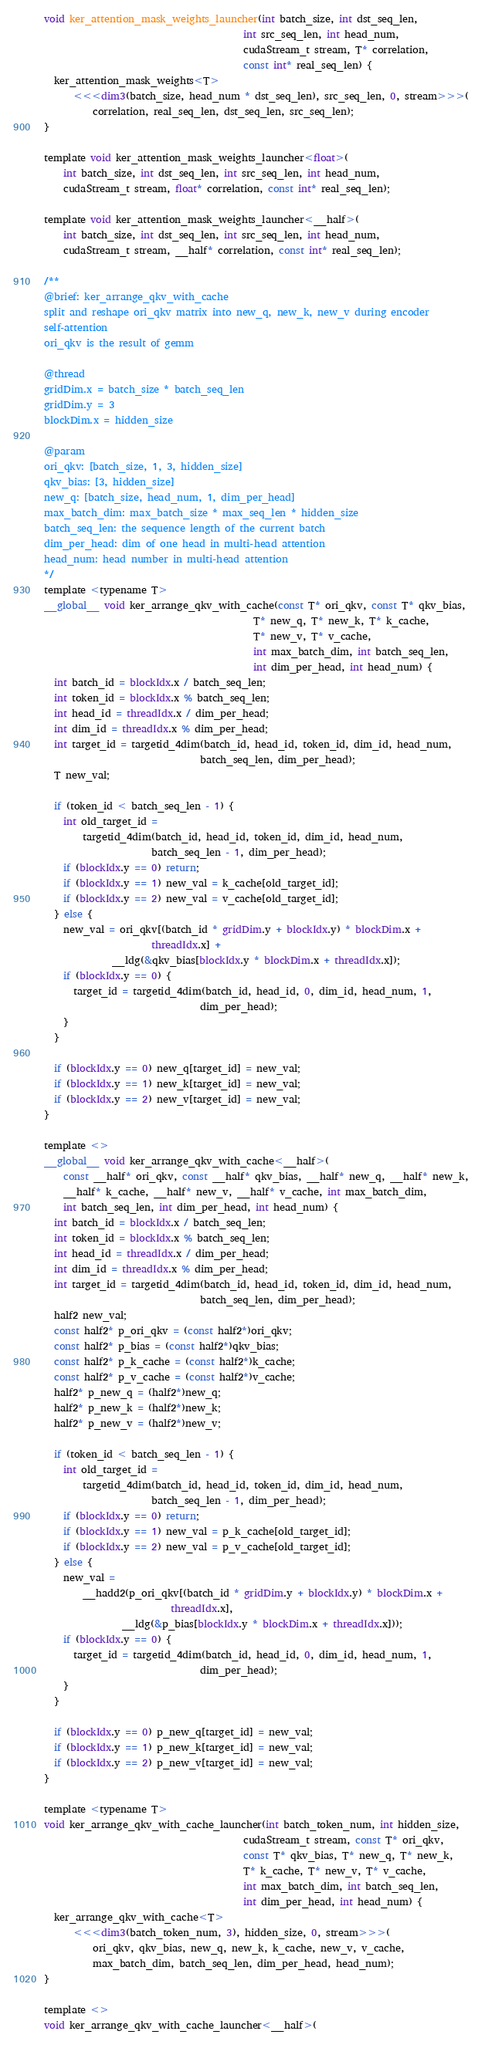Convert code to text. <code><loc_0><loc_0><loc_500><loc_500><_Cuda_>void ker_attention_mask_weights_launcher(int batch_size, int dst_seq_len,
                                         int src_seq_len, int head_num,
                                         cudaStream_t stream, T* correlation,
                                         const int* real_seq_len) {
  ker_attention_mask_weights<T>
      <<<dim3(batch_size, head_num * dst_seq_len), src_seq_len, 0, stream>>>(
          correlation, real_seq_len, dst_seq_len, src_seq_len);
}

template void ker_attention_mask_weights_launcher<float>(
    int batch_size, int dst_seq_len, int src_seq_len, int head_num,
    cudaStream_t stream, float* correlation, const int* real_seq_len);

template void ker_attention_mask_weights_launcher<__half>(
    int batch_size, int dst_seq_len, int src_seq_len, int head_num,
    cudaStream_t stream, __half* correlation, const int* real_seq_len);

/**
@brief: ker_arrange_qkv_with_cache
split and reshape ori_qkv matrix into new_q, new_k, new_v during encoder
self-attention
ori_qkv is the result of gemm

@thread
gridDim.x = batch_size * batch_seq_len
gridDim.y = 3
blockDim.x = hidden_size

@param
ori_qkv: [batch_size, 1, 3, hidden_size]
qkv_bias: [3, hidden_size]
new_q: [batch_size, head_num, 1, dim_per_head]
max_batch_dim: max_batch_size * max_seq_len * hidden_size
batch_seq_len: the sequence length of the current batch
dim_per_head: dim of one head in multi-head attention
head_num: head number in multi-head attention
*/
template <typename T>
__global__ void ker_arrange_qkv_with_cache(const T* ori_qkv, const T* qkv_bias,
                                           T* new_q, T* new_k, T* k_cache,
                                           T* new_v, T* v_cache,
                                           int max_batch_dim, int batch_seq_len,
                                           int dim_per_head, int head_num) {
  int batch_id = blockIdx.x / batch_seq_len;
  int token_id = blockIdx.x % batch_seq_len;
  int head_id = threadIdx.x / dim_per_head;
  int dim_id = threadIdx.x % dim_per_head;
  int target_id = targetid_4dim(batch_id, head_id, token_id, dim_id, head_num,
                                batch_seq_len, dim_per_head);
  T new_val;

  if (token_id < batch_seq_len - 1) {
    int old_target_id =
        targetid_4dim(batch_id, head_id, token_id, dim_id, head_num,
                      batch_seq_len - 1, dim_per_head);
    if (blockIdx.y == 0) return;
    if (blockIdx.y == 1) new_val = k_cache[old_target_id];
    if (blockIdx.y == 2) new_val = v_cache[old_target_id];
  } else {
    new_val = ori_qkv[(batch_id * gridDim.y + blockIdx.y) * blockDim.x +
                      threadIdx.x] +
              __ldg(&qkv_bias[blockIdx.y * blockDim.x + threadIdx.x]);
    if (blockIdx.y == 0) {
      target_id = targetid_4dim(batch_id, head_id, 0, dim_id, head_num, 1,
                                dim_per_head);
    }
  }

  if (blockIdx.y == 0) new_q[target_id] = new_val;
  if (blockIdx.y == 1) new_k[target_id] = new_val;
  if (blockIdx.y == 2) new_v[target_id] = new_val;
}

template <>
__global__ void ker_arrange_qkv_with_cache<__half>(
    const __half* ori_qkv, const __half* qkv_bias, __half* new_q, __half* new_k,
    __half* k_cache, __half* new_v, __half* v_cache, int max_batch_dim,
    int batch_seq_len, int dim_per_head, int head_num) {
  int batch_id = blockIdx.x / batch_seq_len;
  int token_id = blockIdx.x % batch_seq_len;
  int head_id = threadIdx.x / dim_per_head;
  int dim_id = threadIdx.x % dim_per_head;
  int target_id = targetid_4dim(batch_id, head_id, token_id, dim_id, head_num,
                                batch_seq_len, dim_per_head);
  half2 new_val;
  const half2* p_ori_qkv = (const half2*)ori_qkv;
  const half2* p_bias = (const half2*)qkv_bias;
  const half2* p_k_cache = (const half2*)k_cache;
  const half2* p_v_cache = (const half2*)v_cache;
  half2* p_new_q = (half2*)new_q;
  half2* p_new_k = (half2*)new_k;
  half2* p_new_v = (half2*)new_v;

  if (token_id < batch_seq_len - 1) {
    int old_target_id =
        targetid_4dim(batch_id, head_id, token_id, dim_id, head_num,
                      batch_seq_len - 1, dim_per_head);
    if (blockIdx.y == 0) return;
    if (blockIdx.y == 1) new_val = p_k_cache[old_target_id];
    if (blockIdx.y == 2) new_val = p_v_cache[old_target_id];
  } else {
    new_val =
        __hadd2(p_ori_qkv[(batch_id * gridDim.y + blockIdx.y) * blockDim.x +
                          threadIdx.x],
                __ldg(&p_bias[blockIdx.y * blockDim.x + threadIdx.x]));
    if (blockIdx.y == 0) {
      target_id = targetid_4dim(batch_id, head_id, 0, dim_id, head_num, 1,
                                dim_per_head);
    }
  }

  if (blockIdx.y == 0) p_new_q[target_id] = new_val;
  if (blockIdx.y == 1) p_new_k[target_id] = new_val;
  if (blockIdx.y == 2) p_new_v[target_id] = new_val;
}

template <typename T>
void ker_arrange_qkv_with_cache_launcher(int batch_token_num, int hidden_size,
                                         cudaStream_t stream, const T* ori_qkv,
                                         const T* qkv_bias, T* new_q, T* new_k,
                                         T* k_cache, T* new_v, T* v_cache,
                                         int max_batch_dim, int batch_seq_len,
                                         int dim_per_head, int head_num) {
  ker_arrange_qkv_with_cache<T>
      <<<dim3(batch_token_num, 3), hidden_size, 0, stream>>>(
          ori_qkv, qkv_bias, new_q, new_k, k_cache, new_v, v_cache,
          max_batch_dim, batch_seq_len, dim_per_head, head_num);
}

template <>
void ker_arrange_qkv_with_cache_launcher<__half>(</code> 